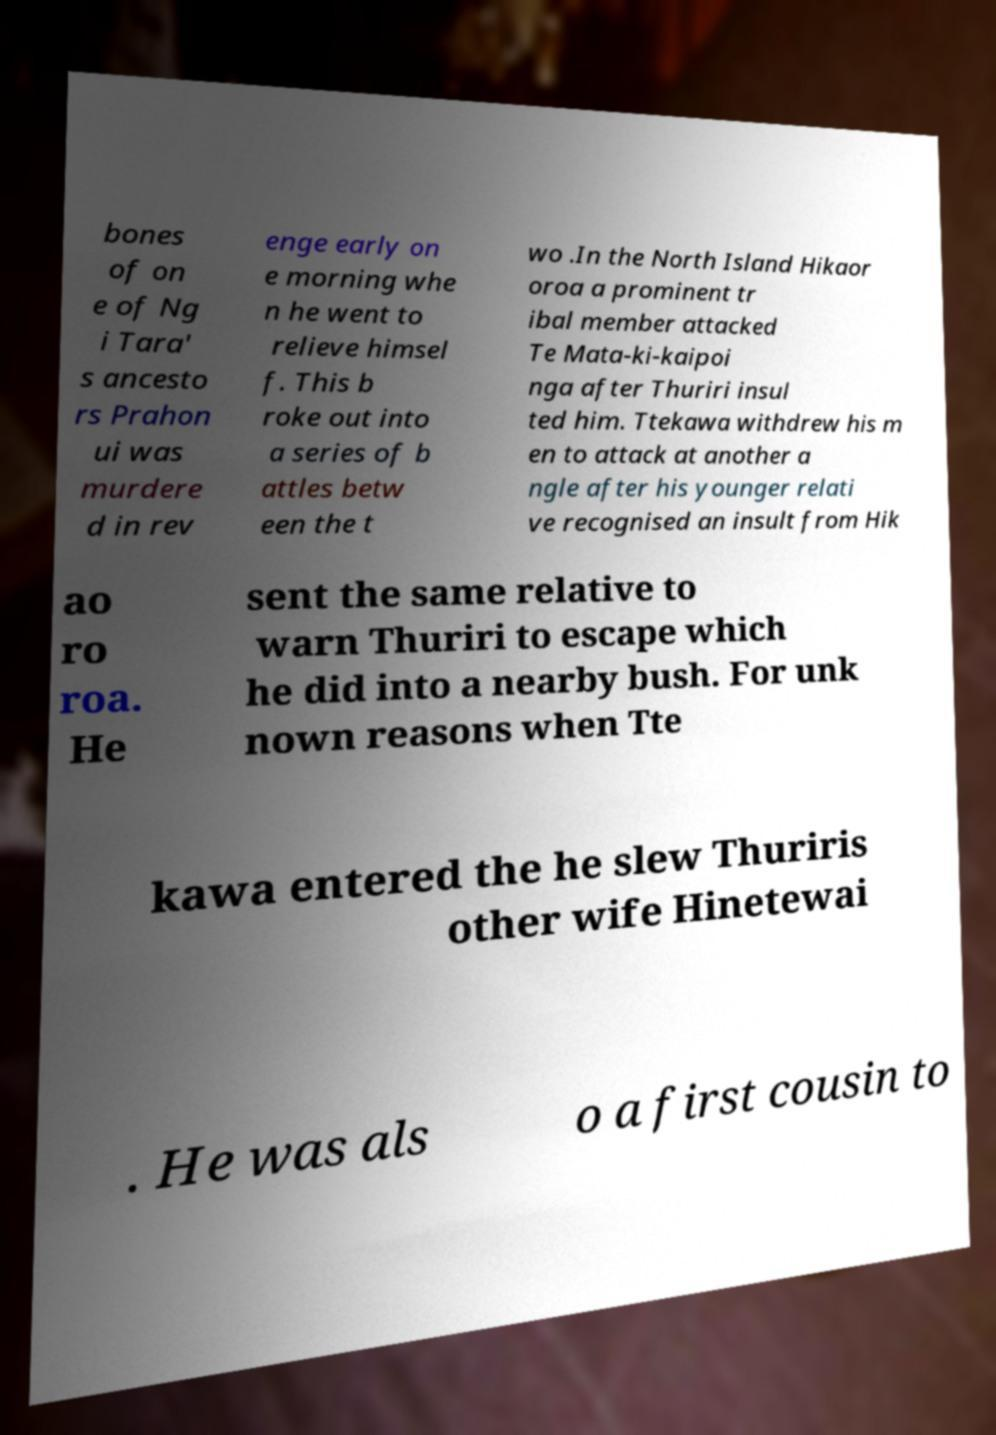What messages or text are displayed in this image? I need them in a readable, typed format. bones of on e of Ng i Tara' s ancesto rs Prahon ui was murdere d in rev enge early on e morning whe n he went to relieve himsel f. This b roke out into a series of b attles betw een the t wo .In the North Island Hikaor oroa a prominent tr ibal member attacked Te Mata-ki-kaipoi nga after Thuriri insul ted him. Ttekawa withdrew his m en to attack at another a ngle after his younger relati ve recognised an insult from Hik ao ro roa. He sent the same relative to warn Thuriri to escape which he did into a nearby bush. For unk nown reasons when Tte kawa entered the he slew Thuriris other wife Hinetewai . He was als o a first cousin to 